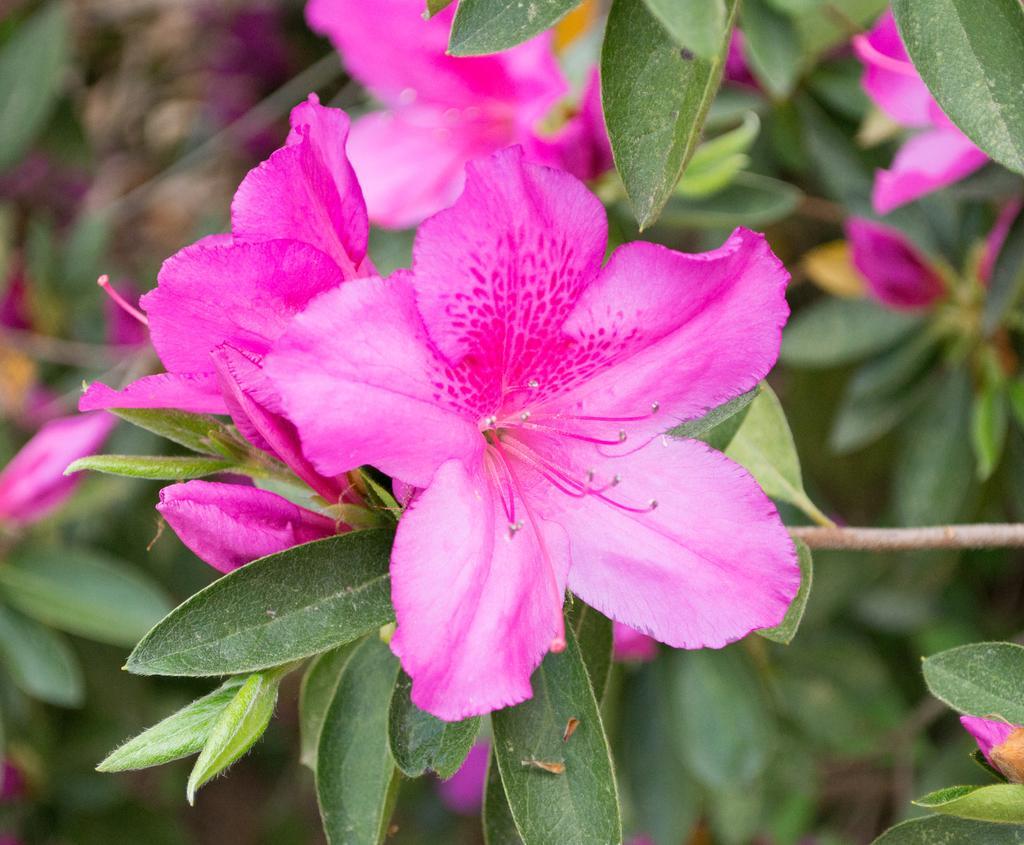Please provide a concise description of this image. In this image I can see the flowers to the plants. These flowers are in pink color. 